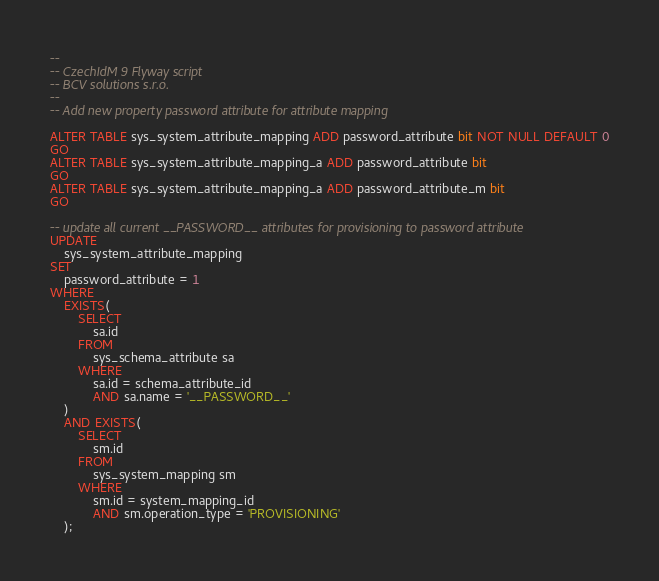Convert code to text. <code><loc_0><loc_0><loc_500><loc_500><_SQL_>--
-- CzechIdM 9 Flyway script 
-- BCV solutions s.r.o.
--
-- Add new property password attribute for attribute mapping

ALTER TABLE sys_system_attribute_mapping ADD password_attribute bit NOT NULL DEFAULT 0
GO
ALTER TABLE sys_system_attribute_mapping_a ADD password_attribute bit
GO
ALTER TABLE sys_system_attribute_mapping_a ADD password_attribute_m bit
GO

-- update all current __PASSWORD__ attributes for provisioning to password attribute
UPDATE
	sys_system_attribute_mapping
SET
	password_attribute = 1
WHERE
	EXISTS(
		SELECT
			sa.id
		FROM
			sys_schema_attribute sa
		WHERE
			sa.id = schema_attribute_id
			AND sa.name = '__PASSWORD__'
	)
	AND EXISTS(
		SELECT
			sm.id
		FROM
			sys_system_mapping sm
		WHERE
			sm.id = system_mapping_id
			AND sm.operation_type = 'PROVISIONING'
	);</code> 